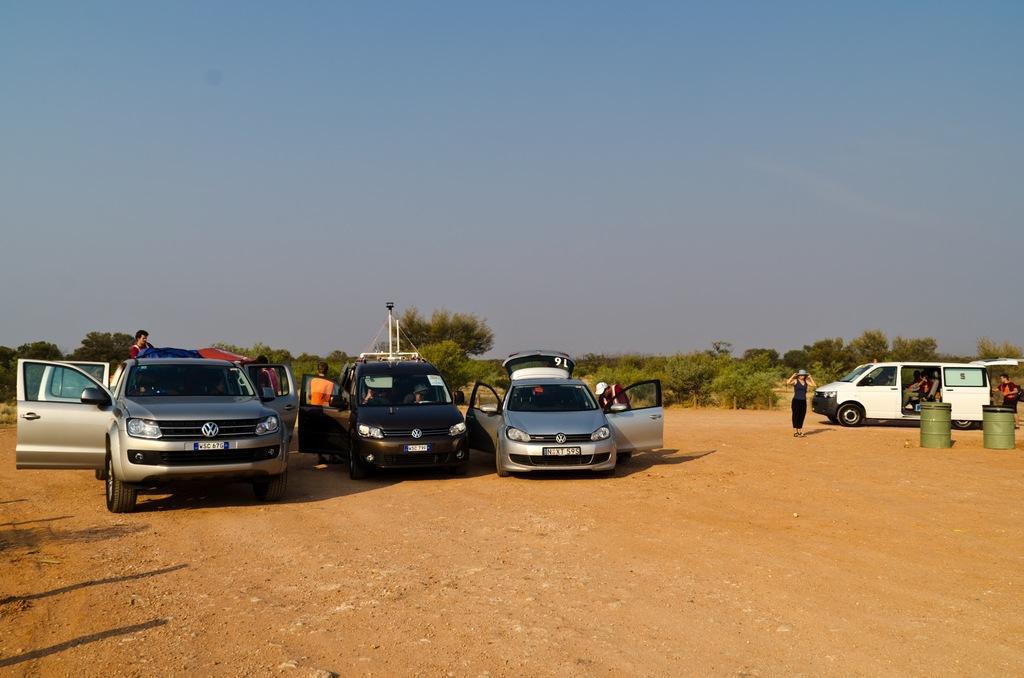Describe this image in one or two sentences. In this picture we can observe some cars on the ground. We can observe two green color drums on the right side. There are some members standing in this picture. In the background there are trees and a sky. 